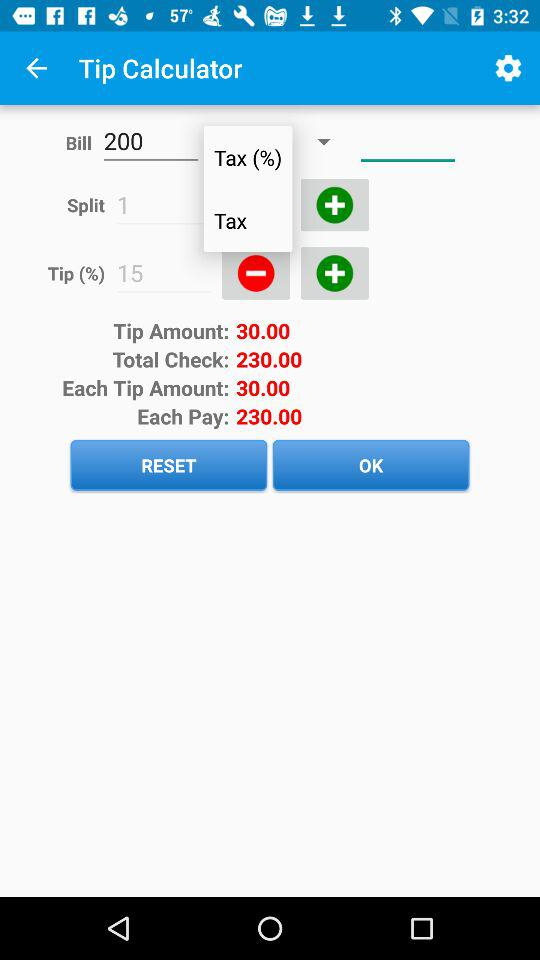For what category is the amount of 200 given? The category is "Bill". 